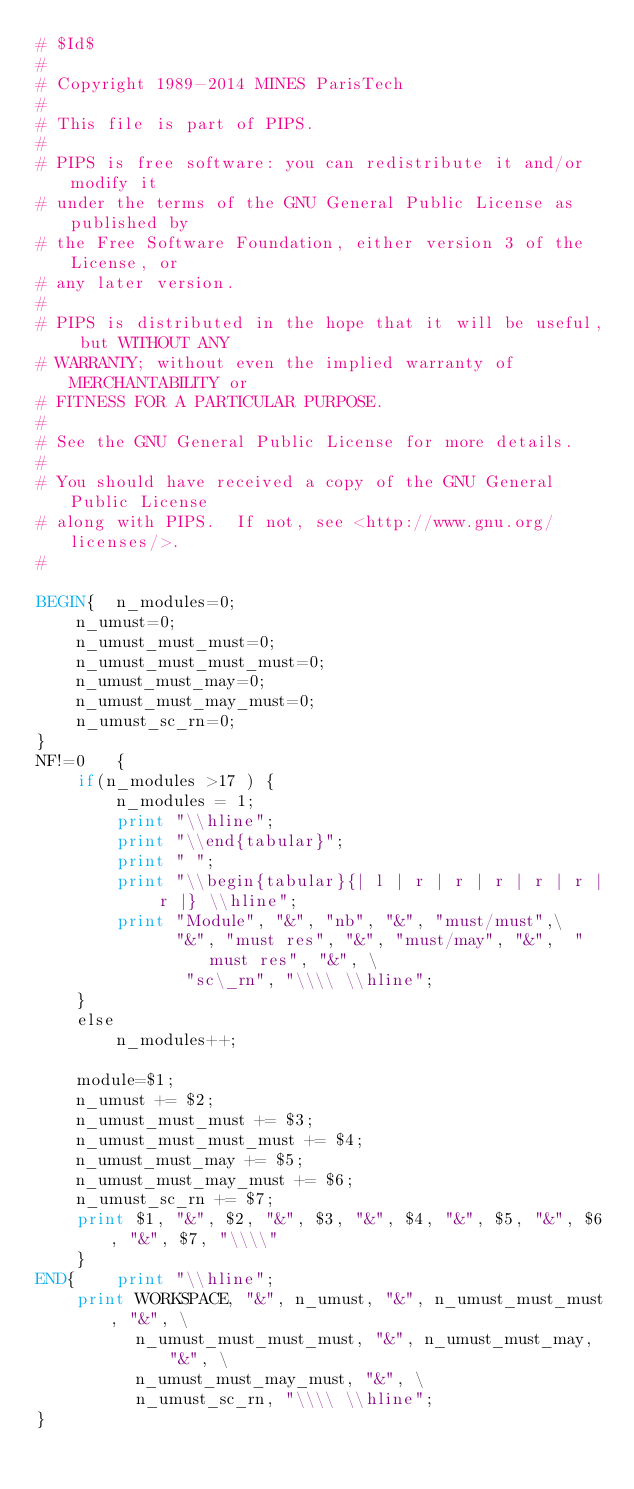Convert code to text. <code><loc_0><loc_0><loc_500><loc_500><_Awk_># $Id$
#
# Copyright 1989-2014 MINES ParisTech
#
# This file is part of PIPS.
#
# PIPS is free software: you can redistribute it and/or modify it
# under the terms of the GNU General Public License as published by
# the Free Software Foundation, either version 3 of the License, or
# any later version.
#
# PIPS is distributed in the hope that it will be useful, but WITHOUT ANY
# WARRANTY; without even the implied warranty of MERCHANTABILITY or
# FITNESS FOR A PARTICULAR PURPOSE.
#
# See the GNU General Public License for more details.
#
# You should have received a copy of the GNU General Public License
# along with PIPS.  If not, see <http://www.gnu.org/licenses/>.
#

BEGIN{  n_modules=0;
	n_umust=0;
	n_umust_must_must=0;
	n_umust_must_must_must=0;
	n_umust_must_may=0;
	n_umust_must_may_must=0;
	n_umust_sc_rn=0;
}
NF!=0	{
	if(n_modules >17 ) {
		n_modules = 1;
		print "\\hline";
		print "\\end{tabular}";
		print " ";
		print "\\begin{tabular}{| l | r | r | r | r | r | r |} \\hline";
		print "Module", "&", "nb", "&", "must/must",\
		      "&", "must res", "&", "must/may", "&",  "must res", "&", \
		       "sc\_rn", "\\\\ \\hline";
	}
	else
		n_modules++;

	module=$1;
	n_umust += $2;
	n_umust_must_must += $3;
	n_umust_must_must_must += $4;
	n_umust_must_may += $5;	
	n_umust_must_may_must += $6;
	n_umust_sc_rn += $7;
	print $1, "&", $2, "&", $3, "&", $4, "&", $5, "&", $6, "&", $7, "\\\\"
	}
END{	print "\\hline";
	print WORKSPACE, "&", n_umust, "&", n_umust_must_must, "&", \
	      n_umust_must_must_must, "&", n_umust_must_may, "&", \
	      n_umust_must_may_must, "&", \
	      n_umust_sc_rn, "\\\\ \\hline";
}
</code> 